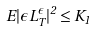Convert formula to latex. <formula><loc_0><loc_0><loc_500><loc_500>E | \epsilon L _ { T } ^ { \epsilon } | ^ { 2 } \leq K _ { 1 }</formula> 